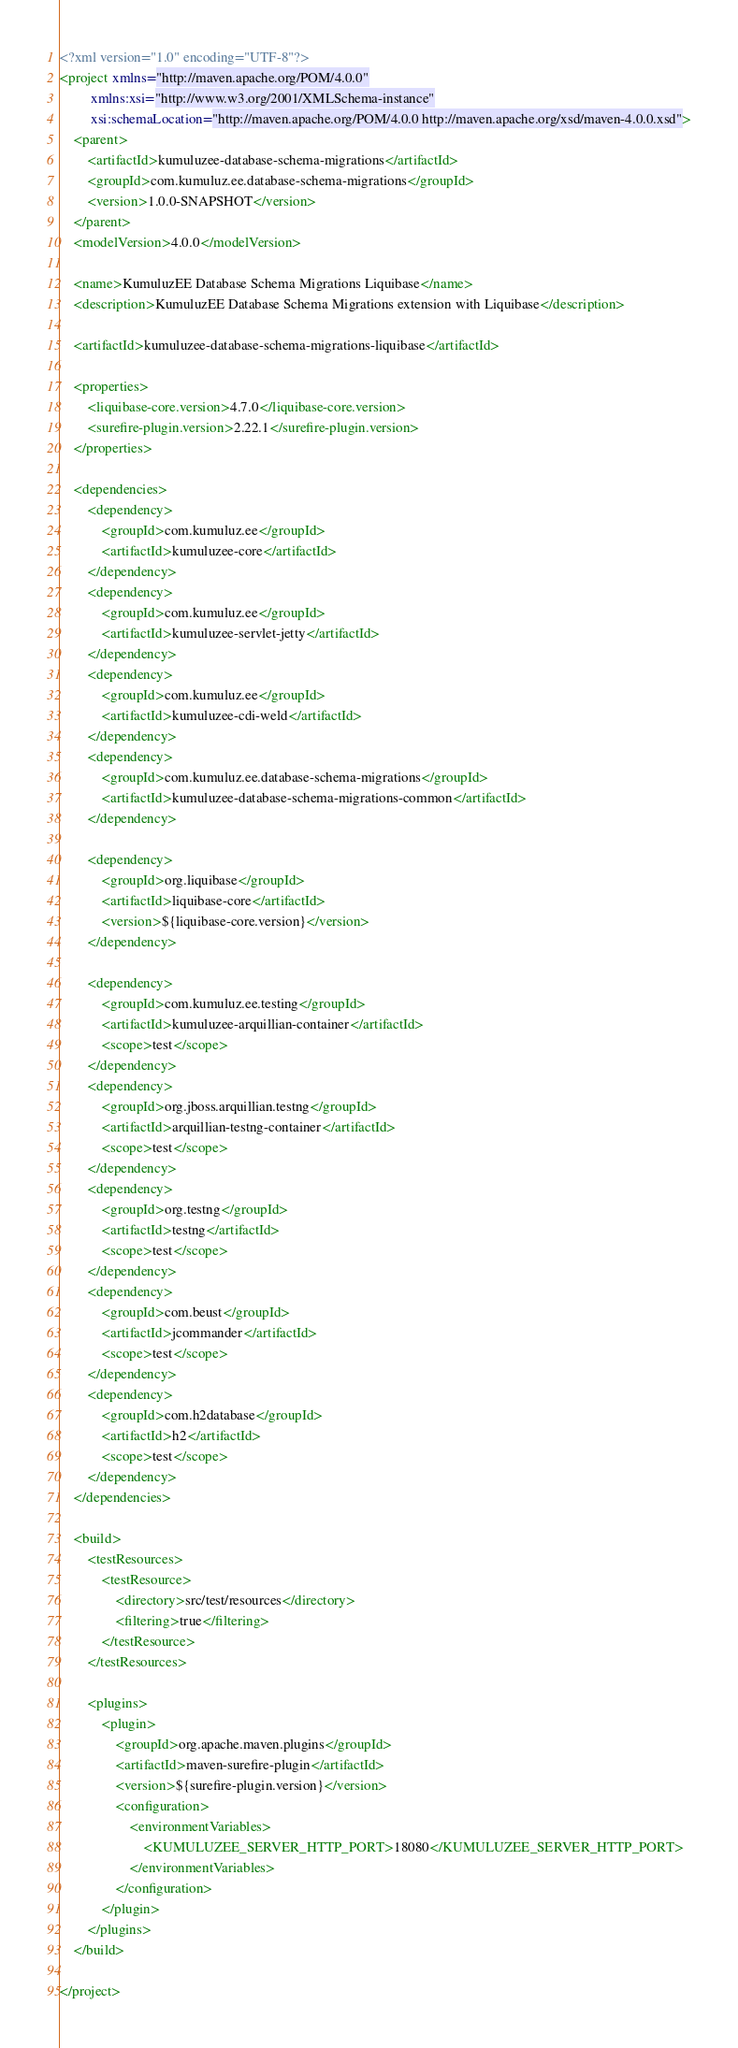Convert code to text. <code><loc_0><loc_0><loc_500><loc_500><_XML_><?xml version="1.0" encoding="UTF-8"?>
<project xmlns="http://maven.apache.org/POM/4.0.0"
         xmlns:xsi="http://www.w3.org/2001/XMLSchema-instance"
         xsi:schemaLocation="http://maven.apache.org/POM/4.0.0 http://maven.apache.org/xsd/maven-4.0.0.xsd">
    <parent>
        <artifactId>kumuluzee-database-schema-migrations</artifactId>
        <groupId>com.kumuluz.ee.database-schema-migrations</groupId>
        <version>1.0.0-SNAPSHOT</version>
    </parent>
    <modelVersion>4.0.0</modelVersion>

    <name>KumuluzEE Database Schema Migrations Liquibase</name>
    <description>KumuluzEE Database Schema Migrations extension with Liquibase</description>

    <artifactId>kumuluzee-database-schema-migrations-liquibase</artifactId>

    <properties>
        <liquibase-core.version>4.7.0</liquibase-core.version>
        <surefire-plugin.version>2.22.1</surefire-plugin.version>
    </properties>

    <dependencies>
        <dependency>
            <groupId>com.kumuluz.ee</groupId>
            <artifactId>kumuluzee-core</artifactId>
        </dependency>
        <dependency>
            <groupId>com.kumuluz.ee</groupId>
            <artifactId>kumuluzee-servlet-jetty</artifactId>
        </dependency>
        <dependency>
            <groupId>com.kumuluz.ee</groupId>
            <artifactId>kumuluzee-cdi-weld</artifactId>
        </dependency>
        <dependency>
            <groupId>com.kumuluz.ee.database-schema-migrations</groupId>
            <artifactId>kumuluzee-database-schema-migrations-common</artifactId>
        </dependency>

        <dependency>
            <groupId>org.liquibase</groupId>
            <artifactId>liquibase-core</artifactId>
            <version>${liquibase-core.version}</version>
        </dependency>

        <dependency>
            <groupId>com.kumuluz.ee.testing</groupId>
            <artifactId>kumuluzee-arquillian-container</artifactId>
            <scope>test</scope>
        </dependency>
        <dependency>
            <groupId>org.jboss.arquillian.testng</groupId>
            <artifactId>arquillian-testng-container</artifactId>
            <scope>test</scope>
        </dependency>
        <dependency>
            <groupId>org.testng</groupId>
            <artifactId>testng</artifactId>
            <scope>test</scope>
        </dependency>
        <dependency>
            <groupId>com.beust</groupId>
            <artifactId>jcommander</artifactId>
            <scope>test</scope>
        </dependency>
        <dependency>
            <groupId>com.h2database</groupId>
            <artifactId>h2</artifactId>
            <scope>test</scope>
        </dependency>
    </dependencies>

    <build>
        <testResources>
            <testResource>
                <directory>src/test/resources</directory>
                <filtering>true</filtering>
            </testResource>
        </testResources>

        <plugins>
            <plugin>
                <groupId>org.apache.maven.plugins</groupId>
                <artifactId>maven-surefire-plugin</artifactId>
                <version>${surefire-plugin.version}</version>
                <configuration>
                    <environmentVariables>
                        <KUMULUZEE_SERVER_HTTP_PORT>18080</KUMULUZEE_SERVER_HTTP_PORT>
                    </environmentVariables>
                </configuration>
            </plugin>
        </plugins>
    </build>

</project></code> 